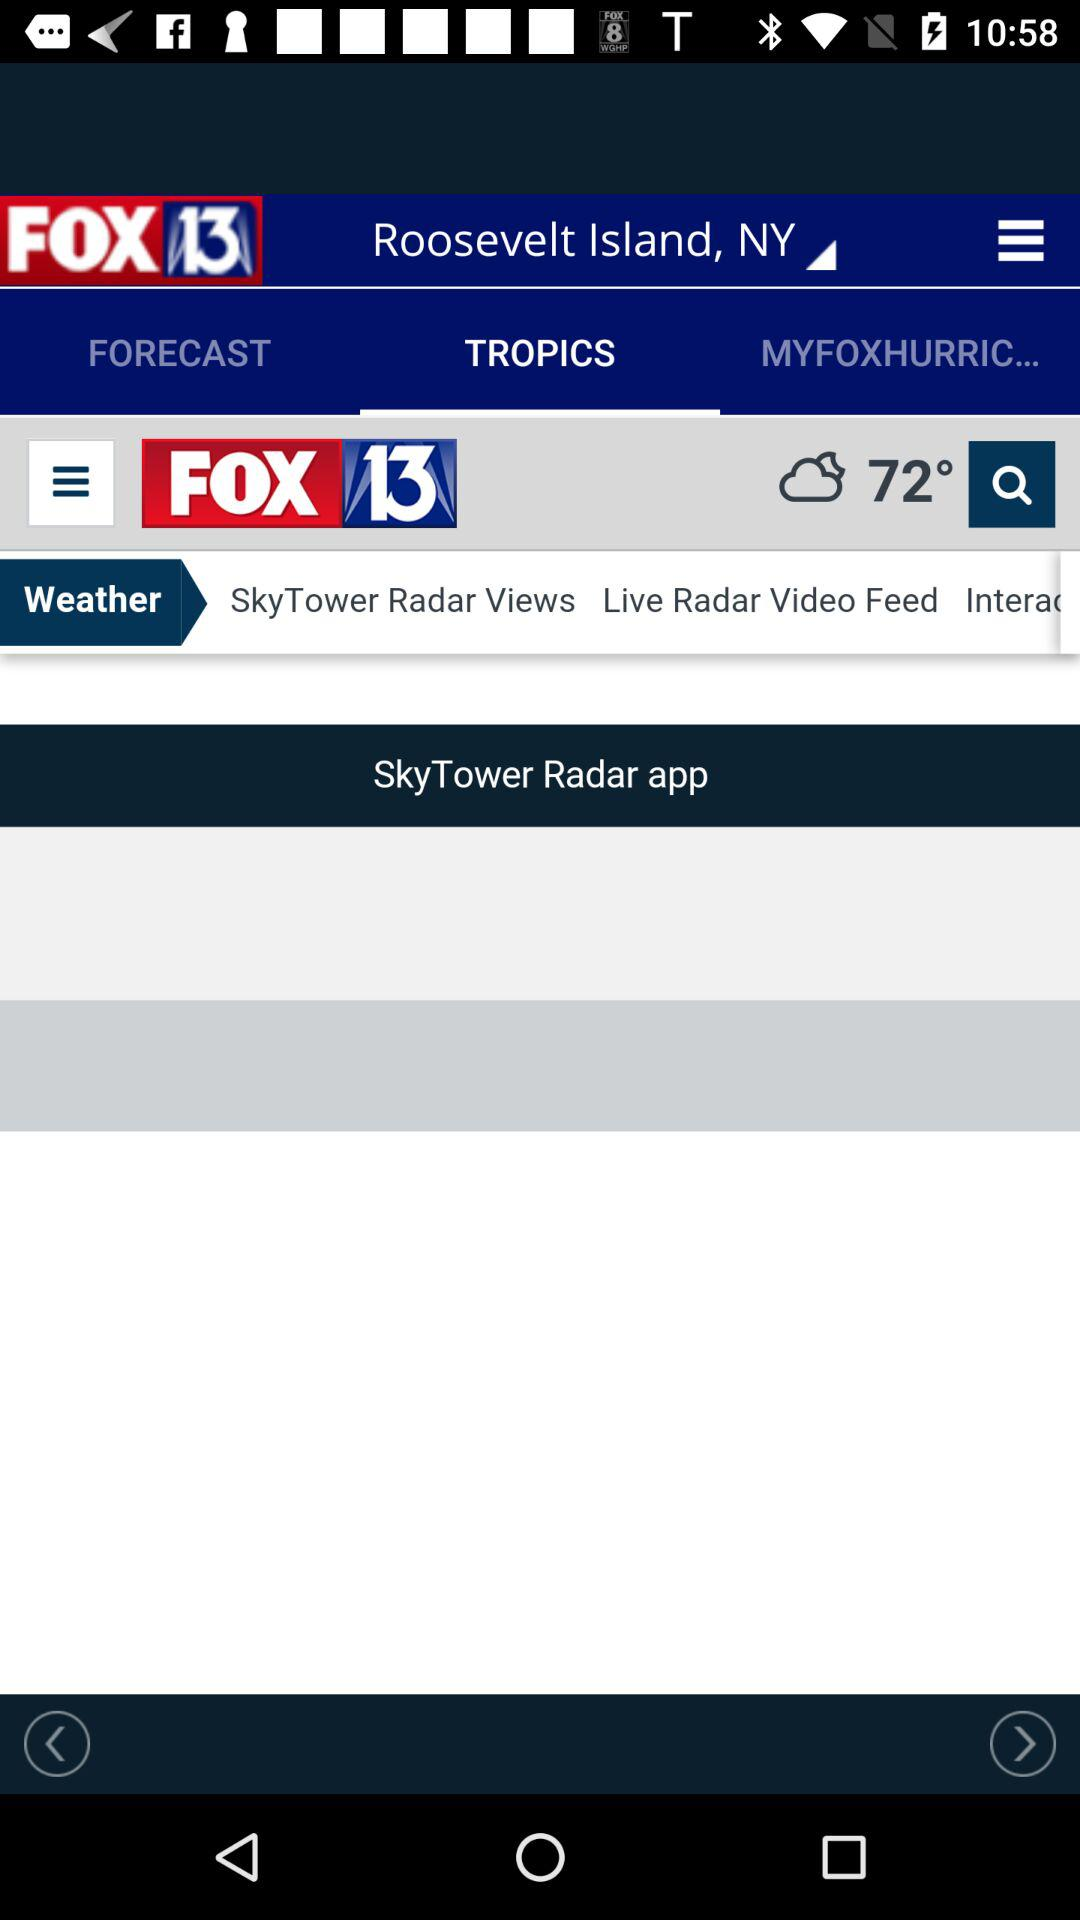Which tab is selected? The selected tab is "TROPICS". 